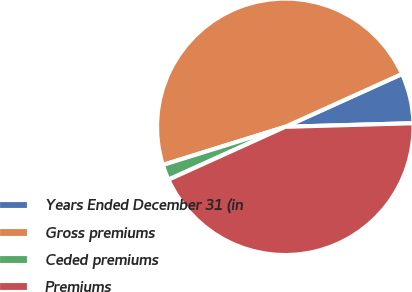Convert chart to OTSL. <chart><loc_0><loc_0><loc_500><loc_500><pie_chart><fcel>Years Ended December 31 (in<fcel>Gross premiums<fcel>Ceded premiums<fcel>Premiums<nl><fcel>6.32%<fcel>48.04%<fcel>1.96%<fcel>43.68%<nl></chart> 